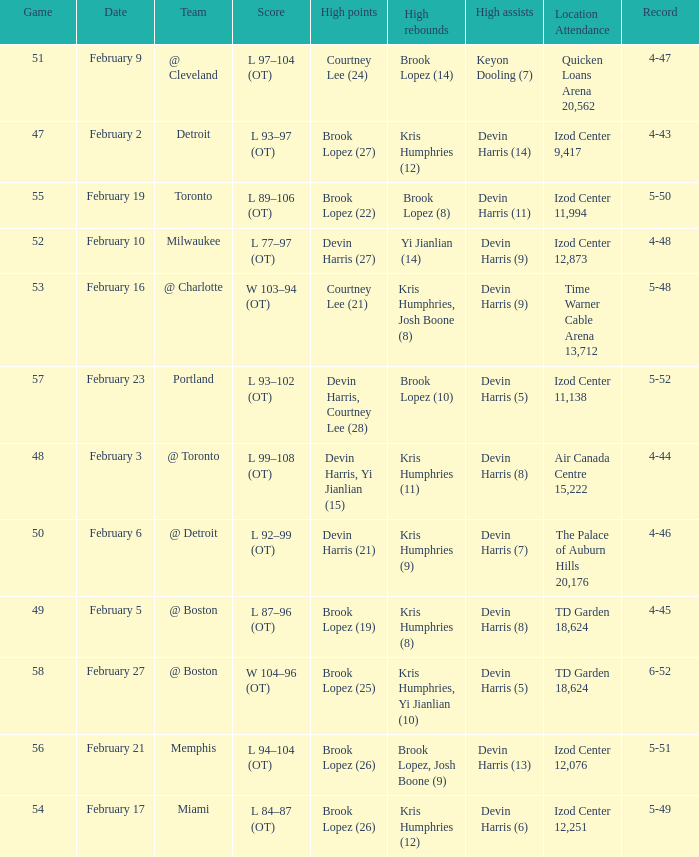Who did the high assists in the game played on February 9? Keyon Dooling (7). 